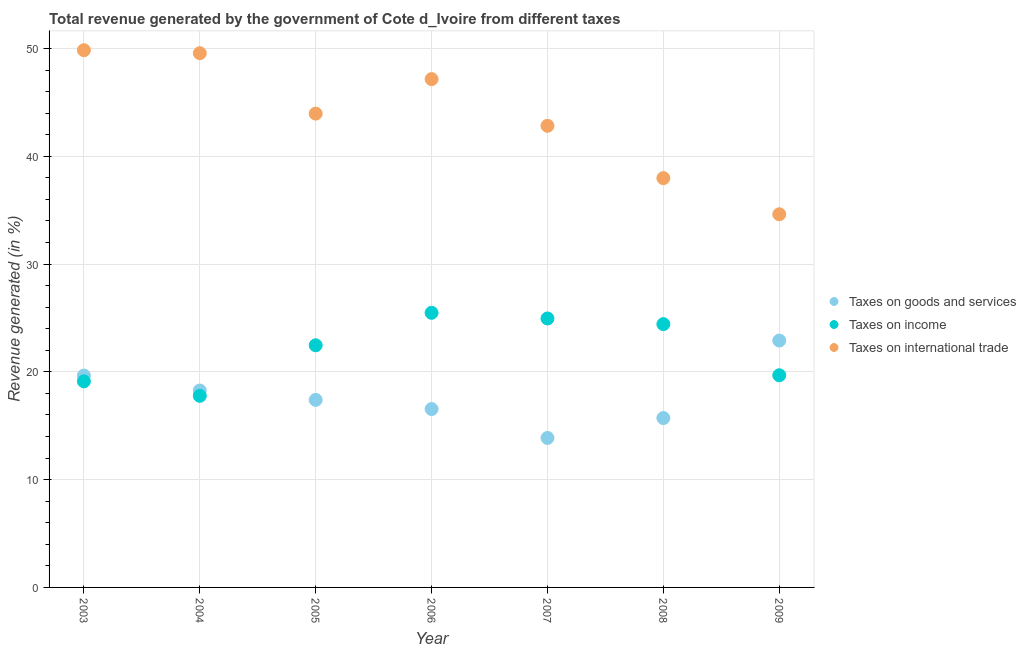What is the percentage of revenue generated by taxes on goods and services in 2009?
Your answer should be very brief. 22.91. Across all years, what is the maximum percentage of revenue generated by taxes on goods and services?
Provide a succinct answer. 22.91. Across all years, what is the minimum percentage of revenue generated by taxes on income?
Your response must be concise. 17.78. In which year was the percentage of revenue generated by tax on international trade maximum?
Your response must be concise. 2003. What is the total percentage of revenue generated by tax on international trade in the graph?
Make the answer very short. 305.97. What is the difference between the percentage of revenue generated by taxes on income in 2006 and that in 2008?
Provide a short and direct response. 1.05. What is the difference between the percentage of revenue generated by taxes on goods and services in 2009 and the percentage of revenue generated by tax on international trade in 2005?
Keep it short and to the point. -21.06. What is the average percentage of revenue generated by tax on international trade per year?
Your response must be concise. 43.71. In the year 2004, what is the difference between the percentage of revenue generated by taxes on income and percentage of revenue generated by taxes on goods and services?
Your answer should be compact. -0.49. What is the ratio of the percentage of revenue generated by tax on international trade in 2006 to that in 2007?
Provide a short and direct response. 1.1. Is the percentage of revenue generated by taxes on income in 2003 less than that in 2009?
Your answer should be compact. Yes. Is the difference between the percentage of revenue generated by taxes on income in 2007 and 2008 greater than the difference between the percentage of revenue generated by taxes on goods and services in 2007 and 2008?
Make the answer very short. Yes. What is the difference between the highest and the second highest percentage of revenue generated by taxes on income?
Ensure brevity in your answer.  0.52. What is the difference between the highest and the lowest percentage of revenue generated by taxes on goods and services?
Provide a short and direct response. 9.04. Is the sum of the percentage of revenue generated by taxes on income in 2006 and 2009 greater than the maximum percentage of revenue generated by taxes on goods and services across all years?
Offer a terse response. Yes. Is it the case that in every year, the sum of the percentage of revenue generated by taxes on goods and services and percentage of revenue generated by taxes on income is greater than the percentage of revenue generated by tax on international trade?
Keep it short and to the point. No. How many years are there in the graph?
Provide a short and direct response. 7. What is the difference between two consecutive major ticks on the Y-axis?
Your answer should be compact. 10. Does the graph contain grids?
Make the answer very short. Yes. Where does the legend appear in the graph?
Your answer should be very brief. Center right. How many legend labels are there?
Give a very brief answer. 3. What is the title of the graph?
Offer a terse response. Total revenue generated by the government of Cote d_Ivoire from different taxes. What is the label or title of the Y-axis?
Provide a short and direct response. Revenue generated (in %). What is the Revenue generated (in %) of Taxes on goods and services in 2003?
Provide a succinct answer. 19.66. What is the Revenue generated (in %) of Taxes on income in 2003?
Give a very brief answer. 19.12. What is the Revenue generated (in %) of Taxes on international trade in 2003?
Your response must be concise. 49.85. What is the Revenue generated (in %) in Taxes on goods and services in 2004?
Keep it short and to the point. 18.27. What is the Revenue generated (in %) in Taxes on income in 2004?
Keep it short and to the point. 17.78. What is the Revenue generated (in %) of Taxes on international trade in 2004?
Your answer should be very brief. 49.57. What is the Revenue generated (in %) of Taxes on goods and services in 2005?
Give a very brief answer. 17.4. What is the Revenue generated (in %) in Taxes on income in 2005?
Your response must be concise. 22.47. What is the Revenue generated (in %) in Taxes on international trade in 2005?
Your response must be concise. 43.96. What is the Revenue generated (in %) in Taxes on goods and services in 2006?
Your answer should be very brief. 16.55. What is the Revenue generated (in %) of Taxes on income in 2006?
Your answer should be very brief. 25.48. What is the Revenue generated (in %) of Taxes on international trade in 2006?
Ensure brevity in your answer.  47.16. What is the Revenue generated (in %) of Taxes on goods and services in 2007?
Make the answer very short. 13.87. What is the Revenue generated (in %) in Taxes on income in 2007?
Offer a very short reply. 24.96. What is the Revenue generated (in %) in Taxes on international trade in 2007?
Your answer should be compact. 42.83. What is the Revenue generated (in %) of Taxes on goods and services in 2008?
Provide a short and direct response. 15.72. What is the Revenue generated (in %) in Taxes on income in 2008?
Your answer should be very brief. 24.43. What is the Revenue generated (in %) of Taxes on international trade in 2008?
Provide a short and direct response. 37.98. What is the Revenue generated (in %) of Taxes on goods and services in 2009?
Give a very brief answer. 22.91. What is the Revenue generated (in %) of Taxes on income in 2009?
Provide a succinct answer. 19.69. What is the Revenue generated (in %) of Taxes on international trade in 2009?
Offer a very short reply. 34.62. Across all years, what is the maximum Revenue generated (in %) of Taxes on goods and services?
Your response must be concise. 22.91. Across all years, what is the maximum Revenue generated (in %) of Taxes on income?
Provide a succinct answer. 25.48. Across all years, what is the maximum Revenue generated (in %) in Taxes on international trade?
Ensure brevity in your answer.  49.85. Across all years, what is the minimum Revenue generated (in %) of Taxes on goods and services?
Your response must be concise. 13.87. Across all years, what is the minimum Revenue generated (in %) of Taxes on income?
Offer a terse response. 17.78. Across all years, what is the minimum Revenue generated (in %) of Taxes on international trade?
Keep it short and to the point. 34.62. What is the total Revenue generated (in %) of Taxes on goods and services in the graph?
Offer a very short reply. 124.38. What is the total Revenue generated (in %) in Taxes on income in the graph?
Keep it short and to the point. 153.91. What is the total Revenue generated (in %) in Taxes on international trade in the graph?
Ensure brevity in your answer.  305.97. What is the difference between the Revenue generated (in %) of Taxes on goods and services in 2003 and that in 2004?
Give a very brief answer. 1.39. What is the difference between the Revenue generated (in %) of Taxes on income in 2003 and that in 2004?
Keep it short and to the point. 1.34. What is the difference between the Revenue generated (in %) in Taxes on international trade in 2003 and that in 2004?
Make the answer very short. 0.28. What is the difference between the Revenue generated (in %) of Taxes on goods and services in 2003 and that in 2005?
Give a very brief answer. 2.26. What is the difference between the Revenue generated (in %) of Taxes on income in 2003 and that in 2005?
Your answer should be compact. -3.35. What is the difference between the Revenue generated (in %) of Taxes on international trade in 2003 and that in 2005?
Your answer should be compact. 5.88. What is the difference between the Revenue generated (in %) of Taxes on goods and services in 2003 and that in 2006?
Offer a terse response. 3.11. What is the difference between the Revenue generated (in %) in Taxes on income in 2003 and that in 2006?
Your answer should be very brief. -6.36. What is the difference between the Revenue generated (in %) of Taxes on international trade in 2003 and that in 2006?
Provide a short and direct response. 2.68. What is the difference between the Revenue generated (in %) of Taxes on goods and services in 2003 and that in 2007?
Your answer should be compact. 5.79. What is the difference between the Revenue generated (in %) in Taxes on income in 2003 and that in 2007?
Your response must be concise. -5.84. What is the difference between the Revenue generated (in %) of Taxes on international trade in 2003 and that in 2007?
Offer a terse response. 7.02. What is the difference between the Revenue generated (in %) in Taxes on goods and services in 2003 and that in 2008?
Make the answer very short. 3.94. What is the difference between the Revenue generated (in %) of Taxes on income in 2003 and that in 2008?
Your response must be concise. -5.31. What is the difference between the Revenue generated (in %) in Taxes on international trade in 2003 and that in 2008?
Offer a very short reply. 11.87. What is the difference between the Revenue generated (in %) of Taxes on goods and services in 2003 and that in 2009?
Your response must be concise. -3.25. What is the difference between the Revenue generated (in %) of Taxes on income in 2003 and that in 2009?
Keep it short and to the point. -0.57. What is the difference between the Revenue generated (in %) of Taxes on international trade in 2003 and that in 2009?
Your answer should be compact. 15.22. What is the difference between the Revenue generated (in %) in Taxes on goods and services in 2004 and that in 2005?
Your response must be concise. 0.87. What is the difference between the Revenue generated (in %) of Taxes on income in 2004 and that in 2005?
Provide a succinct answer. -4.69. What is the difference between the Revenue generated (in %) in Taxes on international trade in 2004 and that in 2005?
Your answer should be compact. 5.61. What is the difference between the Revenue generated (in %) in Taxes on goods and services in 2004 and that in 2006?
Offer a very short reply. 1.72. What is the difference between the Revenue generated (in %) of Taxes on income in 2004 and that in 2006?
Your answer should be compact. -7.7. What is the difference between the Revenue generated (in %) of Taxes on international trade in 2004 and that in 2006?
Keep it short and to the point. 2.4. What is the difference between the Revenue generated (in %) of Taxes on goods and services in 2004 and that in 2007?
Provide a short and direct response. 4.4. What is the difference between the Revenue generated (in %) in Taxes on income in 2004 and that in 2007?
Your answer should be very brief. -7.18. What is the difference between the Revenue generated (in %) of Taxes on international trade in 2004 and that in 2007?
Offer a terse response. 6.74. What is the difference between the Revenue generated (in %) in Taxes on goods and services in 2004 and that in 2008?
Ensure brevity in your answer.  2.55. What is the difference between the Revenue generated (in %) in Taxes on income in 2004 and that in 2008?
Give a very brief answer. -6.65. What is the difference between the Revenue generated (in %) of Taxes on international trade in 2004 and that in 2008?
Give a very brief answer. 11.59. What is the difference between the Revenue generated (in %) in Taxes on goods and services in 2004 and that in 2009?
Your answer should be compact. -4.64. What is the difference between the Revenue generated (in %) of Taxes on income in 2004 and that in 2009?
Your answer should be compact. -1.91. What is the difference between the Revenue generated (in %) of Taxes on international trade in 2004 and that in 2009?
Your answer should be compact. 14.95. What is the difference between the Revenue generated (in %) of Taxes on goods and services in 2005 and that in 2006?
Keep it short and to the point. 0.85. What is the difference between the Revenue generated (in %) in Taxes on income in 2005 and that in 2006?
Your answer should be very brief. -3.01. What is the difference between the Revenue generated (in %) in Taxes on international trade in 2005 and that in 2006?
Give a very brief answer. -3.2. What is the difference between the Revenue generated (in %) in Taxes on goods and services in 2005 and that in 2007?
Provide a short and direct response. 3.53. What is the difference between the Revenue generated (in %) of Taxes on income in 2005 and that in 2007?
Ensure brevity in your answer.  -2.49. What is the difference between the Revenue generated (in %) in Taxes on international trade in 2005 and that in 2007?
Offer a very short reply. 1.13. What is the difference between the Revenue generated (in %) in Taxes on goods and services in 2005 and that in 2008?
Your response must be concise. 1.69. What is the difference between the Revenue generated (in %) in Taxes on income in 2005 and that in 2008?
Offer a very short reply. -1.96. What is the difference between the Revenue generated (in %) in Taxes on international trade in 2005 and that in 2008?
Provide a succinct answer. 5.99. What is the difference between the Revenue generated (in %) in Taxes on goods and services in 2005 and that in 2009?
Offer a terse response. -5.5. What is the difference between the Revenue generated (in %) of Taxes on income in 2005 and that in 2009?
Make the answer very short. 2.78. What is the difference between the Revenue generated (in %) in Taxes on international trade in 2005 and that in 2009?
Make the answer very short. 9.34. What is the difference between the Revenue generated (in %) in Taxes on goods and services in 2006 and that in 2007?
Give a very brief answer. 2.68. What is the difference between the Revenue generated (in %) of Taxes on income in 2006 and that in 2007?
Your answer should be very brief. 0.52. What is the difference between the Revenue generated (in %) of Taxes on international trade in 2006 and that in 2007?
Make the answer very short. 4.33. What is the difference between the Revenue generated (in %) of Taxes on goods and services in 2006 and that in 2008?
Ensure brevity in your answer.  0.83. What is the difference between the Revenue generated (in %) in Taxes on income in 2006 and that in 2008?
Your response must be concise. 1.05. What is the difference between the Revenue generated (in %) of Taxes on international trade in 2006 and that in 2008?
Your response must be concise. 9.19. What is the difference between the Revenue generated (in %) in Taxes on goods and services in 2006 and that in 2009?
Offer a terse response. -6.36. What is the difference between the Revenue generated (in %) in Taxes on income in 2006 and that in 2009?
Give a very brief answer. 5.79. What is the difference between the Revenue generated (in %) of Taxes on international trade in 2006 and that in 2009?
Keep it short and to the point. 12.54. What is the difference between the Revenue generated (in %) of Taxes on goods and services in 2007 and that in 2008?
Your answer should be very brief. -1.85. What is the difference between the Revenue generated (in %) in Taxes on income in 2007 and that in 2008?
Provide a short and direct response. 0.53. What is the difference between the Revenue generated (in %) in Taxes on international trade in 2007 and that in 2008?
Keep it short and to the point. 4.85. What is the difference between the Revenue generated (in %) of Taxes on goods and services in 2007 and that in 2009?
Make the answer very short. -9.04. What is the difference between the Revenue generated (in %) in Taxes on income in 2007 and that in 2009?
Provide a short and direct response. 5.27. What is the difference between the Revenue generated (in %) in Taxes on international trade in 2007 and that in 2009?
Give a very brief answer. 8.21. What is the difference between the Revenue generated (in %) in Taxes on goods and services in 2008 and that in 2009?
Ensure brevity in your answer.  -7.19. What is the difference between the Revenue generated (in %) of Taxes on income in 2008 and that in 2009?
Keep it short and to the point. 4.74. What is the difference between the Revenue generated (in %) of Taxes on international trade in 2008 and that in 2009?
Provide a short and direct response. 3.35. What is the difference between the Revenue generated (in %) in Taxes on goods and services in 2003 and the Revenue generated (in %) in Taxes on income in 2004?
Make the answer very short. 1.88. What is the difference between the Revenue generated (in %) of Taxes on goods and services in 2003 and the Revenue generated (in %) of Taxes on international trade in 2004?
Provide a short and direct response. -29.91. What is the difference between the Revenue generated (in %) of Taxes on income in 2003 and the Revenue generated (in %) of Taxes on international trade in 2004?
Make the answer very short. -30.45. What is the difference between the Revenue generated (in %) of Taxes on goods and services in 2003 and the Revenue generated (in %) of Taxes on income in 2005?
Your answer should be compact. -2.81. What is the difference between the Revenue generated (in %) of Taxes on goods and services in 2003 and the Revenue generated (in %) of Taxes on international trade in 2005?
Make the answer very short. -24.3. What is the difference between the Revenue generated (in %) in Taxes on income in 2003 and the Revenue generated (in %) in Taxes on international trade in 2005?
Ensure brevity in your answer.  -24.84. What is the difference between the Revenue generated (in %) in Taxes on goods and services in 2003 and the Revenue generated (in %) in Taxes on income in 2006?
Provide a short and direct response. -5.82. What is the difference between the Revenue generated (in %) of Taxes on goods and services in 2003 and the Revenue generated (in %) of Taxes on international trade in 2006?
Provide a succinct answer. -27.5. What is the difference between the Revenue generated (in %) of Taxes on income in 2003 and the Revenue generated (in %) of Taxes on international trade in 2006?
Make the answer very short. -28.04. What is the difference between the Revenue generated (in %) of Taxes on goods and services in 2003 and the Revenue generated (in %) of Taxes on income in 2007?
Offer a terse response. -5.3. What is the difference between the Revenue generated (in %) in Taxes on goods and services in 2003 and the Revenue generated (in %) in Taxes on international trade in 2007?
Keep it short and to the point. -23.17. What is the difference between the Revenue generated (in %) of Taxes on income in 2003 and the Revenue generated (in %) of Taxes on international trade in 2007?
Provide a short and direct response. -23.71. What is the difference between the Revenue generated (in %) in Taxes on goods and services in 2003 and the Revenue generated (in %) in Taxes on income in 2008?
Your answer should be very brief. -4.77. What is the difference between the Revenue generated (in %) in Taxes on goods and services in 2003 and the Revenue generated (in %) in Taxes on international trade in 2008?
Give a very brief answer. -18.32. What is the difference between the Revenue generated (in %) in Taxes on income in 2003 and the Revenue generated (in %) in Taxes on international trade in 2008?
Offer a very short reply. -18.86. What is the difference between the Revenue generated (in %) of Taxes on goods and services in 2003 and the Revenue generated (in %) of Taxes on income in 2009?
Offer a terse response. -0.03. What is the difference between the Revenue generated (in %) of Taxes on goods and services in 2003 and the Revenue generated (in %) of Taxes on international trade in 2009?
Your answer should be compact. -14.96. What is the difference between the Revenue generated (in %) of Taxes on income in 2003 and the Revenue generated (in %) of Taxes on international trade in 2009?
Your answer should be compact. -15.5. What is the difference between the Revenue generated (in %) of Taxes on goods and services in 2004 and the Revenue generated (in %) of Taxes on income in 2005?
Provide a short and direct response. -4.2. What is the difference between the Revenue generated (in %) in Taxes on goods and services in 2004 and the Revenue generated (in %) in Taxes on international trade in 2005?
Your answer should be very brief. -25.69. What is the difference between the Revenue generated (in %) of Taxes on income in 2004 and the Revenue generated (in %) of Taxes on international trade in 2005?
Your answer should be very brief. -26.19. What is the difference between the Revenue generated (in %) in Taxes on goods and services in 2004 and the Revenue generated (in %) in Taxes on income in 2006?
Ensure brevity in your answer.  -7.21. What is the difference between the Revenue generated (in %) in Taxes on goods and services in 2004 and the Revenue generated (in %) in Taxes on international trade in 2006?
Your answer should be very brief. -28.89. What is the difference between the Revenue generated (in %) of Taxes on income in 2004 and the Revenue generated (in %) of Taxes on international trade in 2006?
Your answer should be very brief. -29.39. What is the difference between the Revenue generated (in %) in Taxes on goods and services in 2004 and the Revenue generated (in %) in Taxes on income in 2007?
Offer a terse response. -6.69. What is the difference between the Revenue generated (in %) in Taxes on goods and services in 2004 and the Revenue generated (in %) in Taxes on international trade in 2007?
Your response must be concise. -24.56. What is the difference between the Revenue generated (in %) in Taxes on income in 2004 and the Revenue generated (in %) in Taxes on international trade in 2007?
Give a very brief answer. -25.05. What is the difference between the Revenue generated (in %) in Taxes on goods and services in 2004 and the Revenue generated (in %) in Taxes on income in 2008?
Your answer should be very brief. -6.16. What is the difference between the Revenue generated (in %) in Taxes on goods and services in 2004 and the Revenue generated (in %) in Taxes on international trade in 2008?
Offer a very short reply. -19.71. What is the difference between the Revenue generated (in %) of Taxes on income in 2004 and the Revenue generated (in %) of Taxes on international trade in 2008?
Your answer should be very brief. -20.2. What is the difference between the Revenue generated (in %) in Taxes on goods and services in 2004 and the Revenue generated (in %) in Taxes on income in 2009?
Make the answer very short. -1.42. What is the difference between the Revenue generated (in %) of Taxes on goods and services in 2004 and the Revenue generated (in %) of Taxes on international trade in 2009?
Your answer should be compact. -16.35. What is the difference between the Revenue generated (in %) in Taxes on income in 2004 and the Revenue generated (in %) in Taxes on international trade in 2009?
Ensure brevity in your answer.  -16.85. What is the difference between the Revenue generated (in %) in Taxes on goods and services in 2005 and the Revenue generated (in %) in Taxes on income in 2006?
Your answer should be very brief. -8.08. What is the difference between the Revenue generated (in %) of Taxes on goods and services in 2005 and the Revenue generated (in %) of Taxes on international trade in 2006?
Your answer should be very brief. -29.76. What is the difference between the Revenue generated (in %) in Taxes on income in 2005 and the Revenue generated (in %) in Taxes on international trade in 2006?
Provide a short and direct response. -24.7. What is the difference between the Revenue generated (in %) in Taxes on goods and services in 2005 and the Revenue generated (in %) in Taxes on income in 2007?
Your answer should be very brief. -7.55. What is the difference between the Revenue generated (in %) in Taxes on goods and services in 2005 and the Revenue generated (in %) in Taxes on international trade in 2007?
Give a very brief answer. -25.43. What is the difference between the Revenue generated (in %) of Taxes on income in 2005 and the Revenue generated (in %) of Taxes on international trade in 2007?
Provide a succinct answer. -20.36. What is the difference between the Revenue generated (in %) of Taxes on goods and services in 2005 and the Revenue generated (in %) of Taxes on income in 2008?
Make the answer very short. -7.03. What is the difference between the Revenue generated (in %) of Taxes on goods and services in 2005 and the Revenue generated (in %) of Taxes on international trade in 2008?
Your response must be concise. -20.57. What is the difference between the Revenue generated (in %) in Taxes on income in 2005 and the Revenue generated (in %) in Taxes on international trade in 2008?
Your answer should be compact. -15.51. What is the difference between the Revenue generated (in %) in Taxes on goods and services in 2005 and the Revenue generated (in %) in Taxes on income in 2009?
Your answer should be compact. -2.28. What is the difference between the Revenue generated (in %) in Taxes on goods and services in 2005 and the Revenue generated (in %) in Taxes on international trade in 2009?
Give a very brief answer. -17.22. What is the difference between the Revenue generated (in %) of Taxes on income in 2005 and the Revenue generated (in %) of Taxes on international trade in 2009?
Give a very brief answer. -12.16. What is the difference between the Revenue generated (in %) of Taxes on goods and services in 2006 and the Revenue generated (in %) of Taxes on income in 2007?
Your response must be concise. -8.41. What is the difference between the Revenue generated (in %) of Taxes on goods and services in 2006 and the Revenue generated (in %) of Taxes on international trade in 2007?
Offer a terse response. -26.28. What is the difference between the Revenue generated (in %) of Taxes on income in 2006 and the Revenue generated (in %) of Taxes on international trade in 2007?
Your answer should be very brief. -17.35. What is the difference between the Revenue generated (in %) in Taxes on goods and services in 2006 and the Revenue generated (in %) in Taxes on income in 2008?
Ensure brevity in your answer.  -7.88. What is the difference between the Revenue generated (in %) in Taxes on goods and services in 2006 and the Revenue generated (in %) in Taxes on international trade in 2008?
Provide a short and direct response. -21.43. What is the difference between the Revenue generated (in %) in Taxes on income in 2006 and the Revenue generated (in %) in Taxes on international trade in 2008?
Your answer should be compact. -12.5. What is the difference between the Revenue generated (in %) in Taxes on goods and services in 2006 and the Revenue generated (in %) in Taxes on income in 2009?
Give a very brief answer. -3.13. What is the difference between the Revenue generated (in %) in Taxes on goods and services in 2006 and the Revenue generated (in %) in Taxes on international trade in 2009?
Make the answer very short. -18.07. What is the difference between the Revenue generated (in %) in Taxes on income in 2006 and the Revenue generated (in %) in Taxes on international trade in 2009?
Ensure brevity in your answer.  -9.14. What is the difference between the Revenue generated (in %) in Taxes on goods and services in 2007 and the Revenue generated (in %) in Taxes on income in 2008?
Give a very brief answer. -10.56. What is the difference between the Revenue generated (in %) of Taxes on goods and services in 2007 and the Revenue generated (in %) of Taxes on international trade in 2008?
Make the answer very short. -24.11. What is the difference between the Revenue generated (in %) in Taxes on income in 2007 and the Revenue generated (in %) in Taxes on international trade in 2008?
Provide a short and direct response. -13.02. What is the difference between the Revenue generated (in %) in Taxes on goods and services in 2007 and the Revenue generated (in %) in Taxes on income in 2009?
Ensure brevity in your answer.  -5.82. What is the difference between the Revenue generated (in %) of Taxes on goods and services in 2007 and the Revenue generated (in %) of Taxes on international trade in 2009?
Make the answer very short. -20.75. What is the difference between the Revenue generated (in %) of Taxes on income in 2007 and the Revenue generated (in %) of Taxes on international trade in 2009?
Your response must be concise. -9.67. What is the difference between the Revenue generated (in %) in Taxes on goods and services in 2008 and the Revenue generated (in %) in Taxes on income in 2009?
Your response must be concise. -3.97. What is the difference between the Revenue generated (in %) of Taxes on goods and services in 2008 and the Revenue generated (in %) of Taxes on international trade in 2009?
Your response must be concise. -18.91. What is the difference between the Revenue generated (in %) of Taxes on income in 2008 and the Revenue generated (in %) of Taxes on international trade in 2009?
Keep it short and to the point. -10.19. What is the average Revenue generated (in %) in Taxes on goods and services per year?
Ensure brevity in your answer.  17.77. What is the average Revenue generated (in %) of Taxes on income per year?
Your answer should be compact. 21.99. What is the average Revenue generated (in %) in Taxes on international trade per year?
Make the answer very short. 43.71. In the year 2003, what is the difference between the Revenue generated (in %) in Taxes on goods and services and Revenue generated (in %) in Taxes on income?
Give a very brief answer. 0.54. In the year 2003, what is the difference between the Revenue generated (in %) in Taxes on goods and services and Revenue generated (in %) in Taxes on international trade?
Provide a succinct answer. -30.18. In the year 2003, what is the difference between the Revenue generated (in %) in Taxes on income and Revenue generated (in %) in Taxes on international trade?
Provide a succinct answer. -30.73. In the year 2004, what is the difference between the Revenue generated (in %) in Taxes on goods and services and Revenue generated (in %) in Taxes on income?
Offer a terse response. 0.49. In the year 2004, what is the difference between the Revenue generated (in %) in Taxes on goods and services and Revenue generated (in %) in Taxes on international trade?
Provide a succinct answer. -31.3. In the year 2004, what is the difference between the Revenue generated (in %) of Taxes on income and Revenue generated (in %) of Taxes on international trade?
Provide a short and direct response. -31.79. In the year 2005, what is the difference between the Revenue generated (in %) of Taxes on goods and services and Revenue generated (in %) of Taxes on income?
Ensure brevity in your answer.  -5.06. In the year 2005, what is the difference between the Revenue generated (in %) of Taxes on goods and services and Revenue generated (in %) of Taxes on international trade?
Your answer should be compact. -26.56. In the year 2005, what is the difference between the Revenue generated (in %) of Taxes on income and Revenue generated (in %) of Taxes on international trade?
Ensure brevity in your answer.  -21.49. In the year 2006, what is the difference between the Revenue generated (in %) of Taxes on goods and services and Revenue generated (in %) of Taxes on income?
Your response must be concise. -8.93. In the year 2006, what is the difference between the Revenue generated (in %) in Taxes on goods and services and Revenue generated (in %) in Taxes on international trade?
Make the answer very short. -30.61. In the year 2006, what is the difference between the Revenue generated (in %) in Taxes on income and Revenue generated (in %) in Taxes on international trade?
Offer a very short reply. -21.68. In the year 2007, what is the difference between the Revenue generated (in %) of Taxes on goods and services and Revenue generated (in %) of Taxes on income?
Your answer should be very brief. -11.09. In the year 2007, what is the difference between the Revenue generated (in %) of Taxes on goods and services and Revenue generated (in %) of Taxes on international trade?
Offer a very short reply. -28.96. In the year 2007, what is the difference between the Revenue generated (in %) of Taxes on income and Revenue generated (in %) of Taxes on international trade?
Offer a terse response. -17.87. In the year 2008, what is the difference between the Revenue generated (in %) of Taxes on goods and services and Revenue generated (in %) of Taxes on income?
Keep it short and to the point. -8.71. In the year 2008, what is the difference between the Revenue generated (in %) in Taxes on goods and services and Revenue generated (in %) in Taxes on international trade?
Provide a succinct answer. -22.26. In the year 2008, what is the difference between the Revenue generated (in %) in Taxes on income and Revenue generated (in %) in Taxes on international trade?
Your response must be concise. -13.55. In the year 2009, what is the difference between the Revenue generated (in %) of Taxes on goods and services and Revenue generated (in %) of Taxes on income?
Make the answer very short. 3.22. In the year 2009, what is the difference between the Revenue generated (in %) in Taxes on goods and services and Revenue generated (in %) in Taxes on international trade?
Offer a very short reply. -11.72. In the year 2009, what is the difference between the Revenue generated (in %) of Taxes on income and Revenue generated (in %) of Taxes on international trade?
Keep it short and to the point. -14.94. What is the ratio of the Revenue generated (in %) of Taxes on goods and services in 2003 to that in 2004?
Make the answer very short. 1.08. What is the ratio of the Revenue generated (in %) in Taxes on income in 2003 to that in 2004?
Provide a succinct answer. 1.08. What is the ratio of the Revenue generated (in %) of Taxes on international trade in 2003 to that in 2004?
Provide a succinct answer. 1.01. What is the ratio of the Revenue generated (in %) of Taxes on goods and services in 2003 to that in 2005?
Keep it short and to the point. 1.13. What is the ratio of the Revenue generated (in %) of Taxes on income in 2003 to that in 2005?
Make the answer very short. 0.85. What is the ratio of the Revenue generated (in %) in Taxes on international trade in 2003 to that in 2005?
Your answer should be very brief. 1.13. What is the ratio of the Revenue generated (in %) of Taxes on goods and services in 2003 to that in 2006?
Your response must be concise. 1.19. What is the ratio of the Revenue generated (in %) of Taxes on income in 2003 to that in 2006?
Ensure brevity in your answer.  0.75. What is the ratio of the Revenue generated (in %) in Taxes on international trade in 2003 to that in 2006?
Your answer should be compact. 1.06. What is the ratio of the Revenue generated (in %) of Taxes on goods and services in 2003 to that in 2007?
Ensure brevity in your answer.  1.42. What is the ratio of the Revenue generated (in %) in Taxes on income in 2003 to that in 2007?
Your answer should be compact. 0.77. What is the ratio of the Revenue generated (in %) in Taxes on international trade in 2003 to that in 2007?
Offer a very short reply. 1.16. What is the ratio of the Revenue generated (in %) of Taxes on goods and services in 2003 to that in 2008?
Offer a terse response. 1.25. What is the ratio of the Revenue generated (in %) in Taxes on income in 2003 to that in 2008?
Offer a terse response. 0.78. What is the ratio of the Revenue generated (in %) in Taxes on international trade in 2003 to that in 2008?
Your response must be concise. 1.31. What is the ratio of the Revenue generated (in %) of Taxes on goods and services in 2003 to that in 2009?
Offer a terse response. 0.86. What is the ratio of the Revenue generated (in %) in Taxes on income in 2003 to that in 2009?
Provide a short and direct response. 0.97. What is the ratio of the Revenue generated (in %) in Taxes on international trade in 2003 to that in 2009?
Keep it short and to the point. 1.44. What is the ratio of the Revenue generated (in %) in Taxes on goods and services in 2004 to that in 2005?
Your response must be concise. 1.05. What is the ratio of the Revenue generated (in %) in Taxes on income in 2004 to that in 2005?
Make the answer very short. 0.79. What is the ratio of the Revenue generated (in %) in Taxes on international trade in 2004 to that in 2005?
Your response must be concise. 1.13. What is the ratio of the Revenue generated (in %) of Taxes on goods and services in 2004 to that in 2006?
Provide a succinct answer. 1.1. What is the ratio of the Revenue generated (in %) of Taxes on income in 2004 to that in 2006?
Your answer should be very brief. 0.7. What is the ratio of the Revenue generated (in %) in Taxes on international trade in 2004 to that in 2006?
Offer a terse response. 1.05. What is the ratio of the Revenue generated (in %) of Taxes on goods and services in 2004 to that in 2007?
Provide a succinct answer. 1.32. What is the ratio of the Revenue generated (in %) of Taxes on income in 2004 to that in 2007?
Give a very brief answer. 0.71. What is the ratio of the Revenue generated (in %) of Taxes on international trade in 2004 to that in 2007?
Your answer should be compact. 1.16. What is the ratio of the Revenue generated (in %) of Taxes on goods and services in 2004 to that in 2008?
Ensure brevity in your answer.  1.16. What is the ratio of the Revenue generated (in %) in Taxes on income in 2004 to that in 2008?
Keep it short and to the point. 0.73. What is the ratio of the Revenue generated (in %) in Taxes on international trade in 2004 to that in 2008?
Your answer should be very brief. 1.31. What is the ratio of the Revenue generated (in %) in Taxes on goods and services in 2004 to that in 2009?
Keep it short and to the point. 0.8. What is the ratio of the Revenue generated (in %) of Taxes on income in 2004 to that in 2009?
Provide a short and direct response. 0.9. What is the ratio of the Revenue generated (in %) in Taxes on international trade in 2004 to that in 2009?
Keep it short and to the point. 1.43. What is the ratio of the Revenue generated (in %) of Taxes on goods and services in 2005 to that in 2006?
Give a very brief answer. 1.05. What is the ratio of the Revenue generated (in %) in Taxes on income in 2005 to that in 2006?
Provide a short and direct response. 0.88. What is the ratio of the Revenue generated (in %) of Taxes on international trade in 2005 to that in 2006?
Provide a short and direct response. 0.93. What is the ratio of the Revenue generated (in %) of Taxes on goods and services in 2005 to that in 2007?
Provide a succinct answer. 1.25. What is the ratio of the Revenue generated (in %) of Taxes on income in 2005 to that in 2007?
Provide a succinct answer. 0.9. What is the ratio of the Revenue generated (in %) of Taxes on international trade in 2005 to that in 2007?
Your answer should be compact. 1.03. What is the ratio of the Revenue generated (in %) in Taxes on goods and services in 2005 to that in 2008?
Provide a succinct answer. 1.11. What is the ratio of the Revenue generated (in %) in Taxes on income in 2005 to that in 2008?
Your answer should be compact. 0.92. What is the ratio of the Revenue generated (in %) in Taxes on international trade in 2005 to that in 2008?
Keep it short and to the point. 1.16. What is the ratio of the Revenue generated (in %) in Taxes on goods and services in 2005 to that in 2009?
Ensure brevity in your answer.  0.76. What is the ratio of the Revenue generated (in %) in Taxes on income in 2005 to that in 2009?
Make the answer very short. 1.14. What is the ratio of the Revenue generated (in %) in Taxes on international trade in 2005 to that in 2009?
Offer a terse response. 1.27. What is the ratio of the Revenue generated (in %) in Taxes on goods and services in 2006 to that in 2007?
Your answer should be very brief. 1.19. What is the ratio of the Revenue generated (in %) of Taxes on income in 2006 to that in 2007?
Make the answer very short. 1.02. What is the ratio of the Revenue generated (in %) of Taxes on international trade in 2006 to that in 2007?
Your answer should be compact. 1.1. What is the ratio of the Revenue generated (in %) in Taxes on goods and services in 2006 to that in 2008?
Ensure brevity in your answer.  1.05. What is the ratio of the Revenue generated (in %) of Taxes on income in 2006 to that in 2008?
Offer a very short reply. 1.04. What is the ratio of the Revenue generated (in %) of Taxes on international trade in 2006 to that in 2008?
Provide a succinct answer. 1.24. What is the ratio of the Revenue generated (in %) of Taxes on goods and services in 2006 to that in 2009?
Your answer should be very brief. 0.72. What is the ratio of the Revenue generated (in %) in Taxes on income in 2006 to that in 2009?
Your response must be concise. 1.29. What is the ratio of the Revenue generated (in %) of Taxes on international trade in 2006 to that in 2009?
Provide a succinct answer. 1.36. What is the ratio of the Revenue generated (in %) of Taxes on goods and services in 2007 to that in 2008?
Make the answer very short. 0.88. What is the ratio of the Revenue generated (in %) of Taxes on income in 2007 to that in 2008?
Your response must be concise. 1.02. What is the ratio of the Revenue generated (in %) of Taxes on international trade in 2007 to that in 2008?
Your response must be concise. 1.13. What is the ratio of the Revenue generated (in %) in Taxes on goods and services in 2007 to that in 2009?
Offer a very short reply. 0.61. What is the ratio of the Revenue generated (in %) in Taxes on income in 2007 to that in 2009?
Ensure brevity in your answer.  1.27. What is the ratio of the Revenue generated (in %) of Taxes on international trade in 2007 to that in 2009?
Give a very brief answer. 1.24. What is the ratio of the Revenue generated (in %) of Taxes on goods and services in 2008 to that in 2009?
Provide a succinct answer. 0.69. What is the ratio of the Revenue generated (in %) in Taxes on income in 2008 to that in 2009?
Give a very brief answer. 1.24. What is the ratio of the Revenue generated (in %) of Taxes on international trade in 2008 to that in 2009?
Provide a succinct answer. 1.1. What is the difference between the highest and the second highest Revenue generated (in %) in Taxes on goods and services?
Your answer should be very brief. 3.25. What is the difference between the highest and the second highest Revenue generated (in %) in Taxes on income?
Provide a short and direct response. 0.52. What is the difference between the highest and the second highest Revenue generated (in %) of Taxes on international trade?
Make the answer very short. 0.28. What is the difference between the highest and the lowest Revenue generated (in %) in Taxes on goods and services?
Give a very brief answer. 9.04. What is the difference between the highest and the lowest Revenue generated (in %) in Taxes on income?
Ensure brevity in your answer.  7.7. What is the difference between the highest and the lowest Revenue generated (in %) in Taxes on international trade?
Offer a terse response. 15.22. 